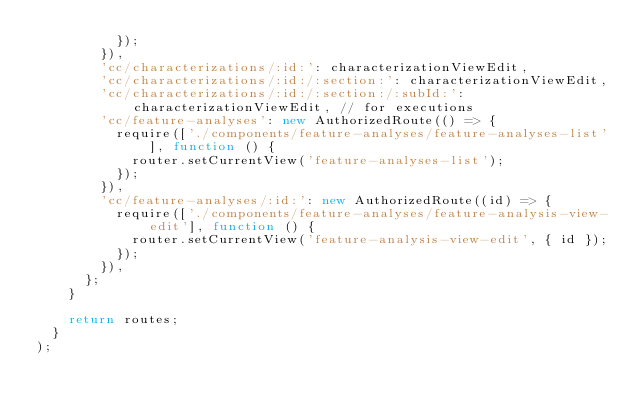Convert code to text. <code><loc_0><loc_0><loc_500><loc_500><_JavaScript_>					});
				}),
				'cc/characterizations/:id:': characterizationViewEdit,
				'cc/characterizations/:id:/:section:': characterizationViewEdit,
				'cc/characterizations/:id:/:section:/:subId:': characterizationViewEdit, // for executions
				'cc/feature-analyses': new AuthorizedRoute(() => {
					require(['./components/feature-analyses/feature-analyses-list'], function () {
						router.setCurrentView('feature-analyses-list');
					});
				}),
				'cc/feature-analyses/:id:': new AuthorizedRoute((id) => {
					require(['./components/feature-analyses/feature-analysis-view-edit'], function () {
						router.setCurrentView('feature-analysis-view-edit', { id });
					});
				}),
			};
		}

		return routes;
	}
);
</code> 